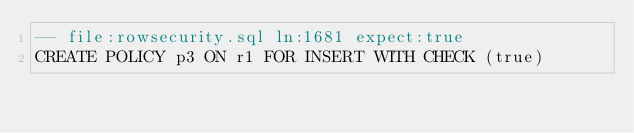<code> <loc_0><loc_0><loc_500><loc_500><_SQL_>-- file:rowsecurity.sql ln:1681 expect:true
CREATE POLICY p3 ON r1 FOR INSERT WITH CHECK (true)
</code> 